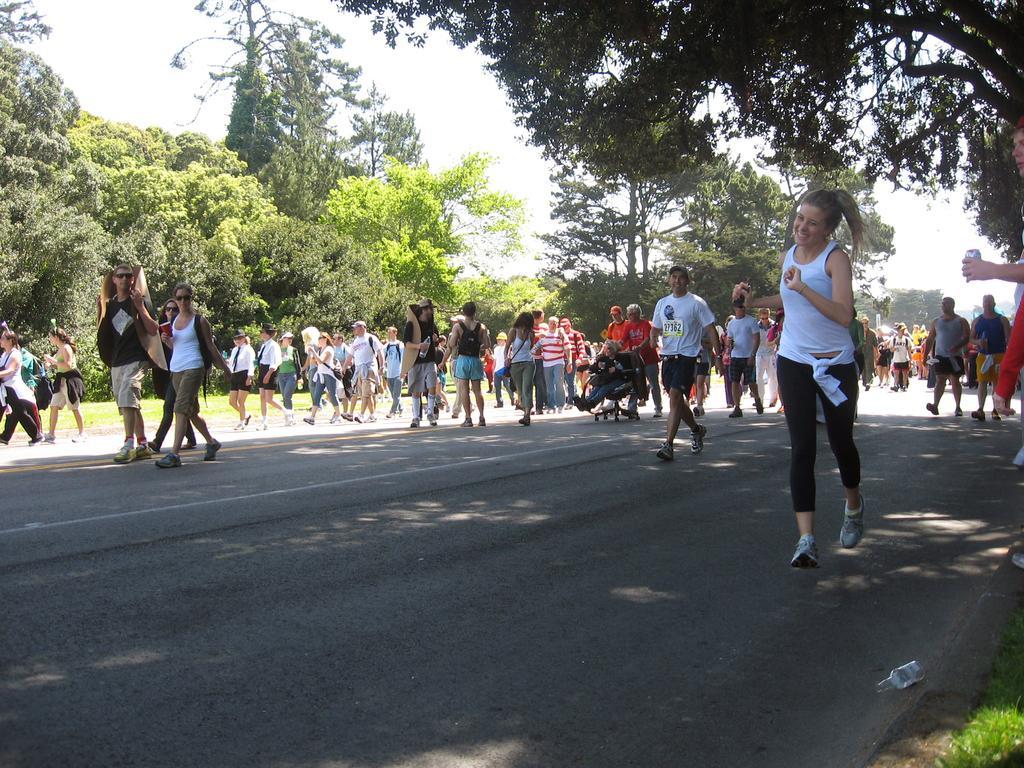Could you give a brief overview of what you see in this image? In this image we a few people walking on the road, a person is sitting on the chair, one person is holding a soda can, another person is holding a sheet, there is a bottle on the road, also we can see the trees, grass, and the sky. 